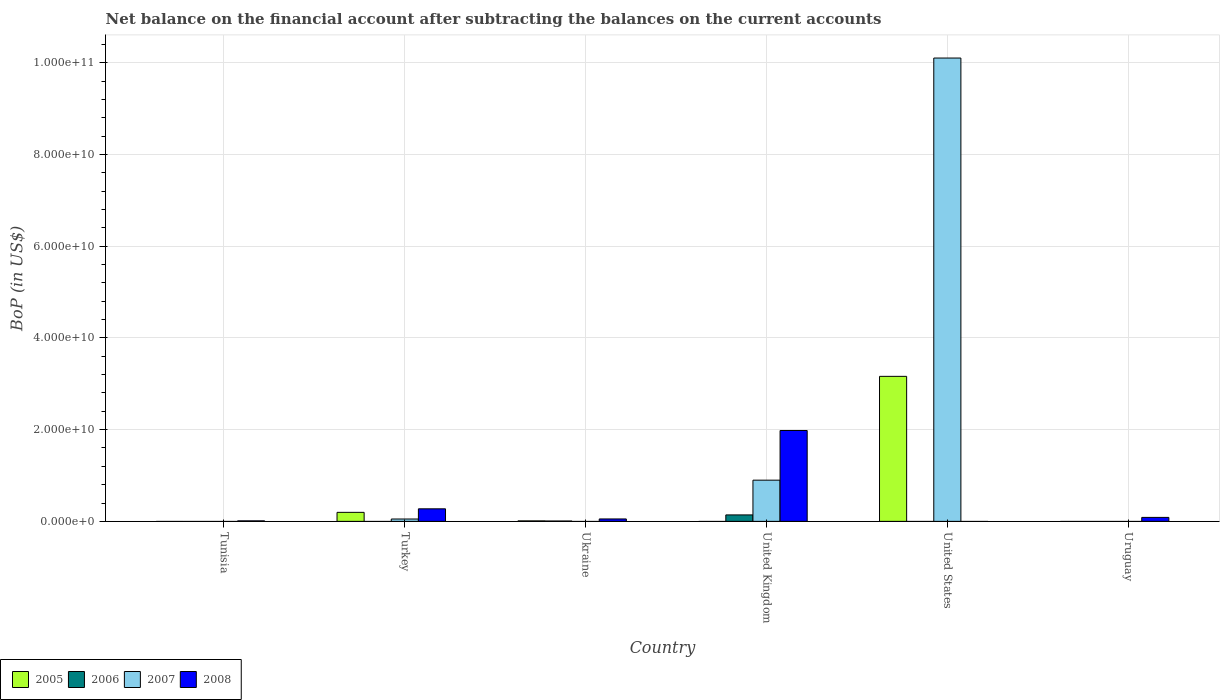How many different coloured bars are there?
Ensure brevity in your answer.  4. Are the number of bars on each tick of the X-axis equal?
Make the answer very short. No. How many bars are there on the 6th tick from the left?
Your answer should be compact. 1. How many bars are there on the 6th tick from the right?
Ensure brevity in your answer.  1. What is the Balance of Payments in 2006 in Ukraine?
Ensure brevity in your answer.  7.60e+07. Across all countries, what is the maximum Balance of Payments in 2007?
Provide a short and direct response. 1.01e+11. In which country was the Balance of Payments in 2005 maximum?
Your response must be concise. United States. What is the total Balance of Payments in 2005 in the graph?
Your answer should be very brief. 3.37e+1. What is the difference between the Balance of Payments in 2007 in United Kingdom and that in United States?
Your answer should be very brief. -9.20e+1. What is the difference between the Balance of Payments in 2008 in Tunisia and the Balance of Payments in 2007 in Ukraine?
Your answer should be compact. 1.13e+08. What is the average Balance of Payments in 2006 per country?
Offer a terse response. 2.47e+08. What is the difference between the Balance of Payments of/in 2005 and Balance of Payments of/in 2006 in Ukraine?
Your answer should be very brief. 2.80e+07. In how many countries, is the Balance of Payments in 2006 greater than 96000000000 US$?
Make the answer very short. 0. What is the difference between the highest and the second highest Balance of Payments in 2007?
Your response must be concise. 9.20e+1. What is the difference between the highest and the lowest Balance of Payments in 2008?
Your answer should be compact. 1.98e+1. In how many countries, is the Balance of Payments in 2005 greater than the average Balance of Payments in 2005 taken over all countries?
Ensure brevity in your answer.  1. Is the sum of the Balance of Payments in 2006 in Ukraine and United Kingdom greater than the maximum Balance of Payments in 2005 across all countries?
Give a very brief answer. No. Is it the case that in every country, the sum of the Balance of Payments in 2006 and Balance of Payments in 2007 is greater than the sum of Balance of Payments in 2008 and Balance of Payments in 2005?
Provide a succinct answer. No. Is it the case that in every country, the sum of the Balance of Payments in 2007 and Balance of Payments in 2005 is greater than the Balance of Payments in 2006?
Make the answer very short. No. Are the values on the major ticks of Y-axis written in scientific E-notation?
Your response must be concise. Yes. Does the graph contain any zero values?
Give a very brief answer. Yes. Where does the legend appear in the graph?
Ensure brevity in your answer.  Bottom left. How many legend labels are there?
Your answer should be very brief. 4. How are the legend labels stacked?
Your answer should be very brief. Horizontal. What is the title of the graph?
Your answer should be compact. Net balance on the financial account after subtracting the balances on the current accounts. What is the label or title of the Y-axis?
Ensure brevity in your answer.  BoP (in US$). What is the BoP (in US$) in 2006 in Tunisia?
Make the answer very short. 0. What is the BoP (in US$) of 2007 in Tunisia?
Provide a short and direct response. 0. What is the BoP (in US$) of 2008 in Tunisia?
Your response must be concise. 1.13e+08. What is the BoP (in US$) in 2005 in Turkey?
Your answer should be compact. 1.96e+09. What is the BoP (in US$) in 2006 in Turkey?
Your answer should be compact. 0. What is the BoP (in US$) in 2007 in Turkey?
Keep it short and to the point. 5.15e+08. What is the BoP (in US$) in 2008 in Turkey?
Your answer should be very brief. 2.73e+09. What is the BoP (in US$) of 2005 in Ukraine?
Provide a succinct answer. 1.04e+08. What is the BoP (in US$) of 2006 in Ukraine?
Make the answer very short. 7.60e+07. What is the BoP (in US$) in 2007 in Ukraine?
Ensure brevity in your answer.  0. What is the BoP (in US$) in 2008 in Ukraine?
Offer a very short reply. 5.26e+08. What is the BoP (in US$) in 2005 in United Kingdom?
Your answer should be very brief. 0. What is the BoP (in US$) in 2006 in United Kingdom?
Offer a terse response. 1.41e+09. What is the BoP (in US$) in 2007 in United Kingdom?
Your answer should be very brief. 8.98e+09. What is the BoP (in US$) of 2008 in United Kingdom?
Offer a very short reply. 1.98e+1. What is the BoP (in US$) of 2005 in United States?
Your answer should be very brief. 3.16e+1. What is the BoP (in US$) of 2006 in United States?
Your answer should be very brief. 0. What is the BoP (in US$) of 2007 in United States?
Offer a terse response. 1.01e+11. What is the BoP (in US$) of 2008 in United States?
Keep it short and to the point. 0. What is the BoP (in US$) of 2008 in Uruguay?
Ensure brevity in your answer.  8.64e+08. Across all countries, what is the maximum BoP (in US$) in 2005?
Provide a short and direct response. 3.16e+1. Across all countries, what is the maximum BoP (in US$) in 2006?
Keep it short and to the point. 1.41e+09. Across all countries, what is the maximum BoP (in US$) in 2007?
Keep it short and to the point. 1.01e+11. Across all countries, what is the maximum BoP (in US$) in 2008?
Your answer should be very brief. 1.98e+1. Across all countries, what is the minimum BoP (in US$) of 2005?
Your answer should be very brief. 0. Across all countries, what is the minimum BoP (in US$) of 2006?
Offer a terse response. 0. Across all countries, what is the minimum BoP (in US$) of 2007?
Your response must be concise. 0. Across all countries, what is the minimum BoP (in US$) of 2008?
Make the answer very short. 0. What is the total BoP (in US$) in 2005 in the graph?
Provide a succinct answer. 3.37e+1. What is the total BoP (in US$) in 2006 in the graph?
Your answer should be compact. 1.48e+09. What is the total BoP (in US$) in 2007 in the graph?
Offer a terse response. 1.11e+11. What is the total BoP (in US$) in 2008 in the graph?
Provide a short and direct response. 2.40e+1. What is the difference between the BoP (in US$) in 2008 in Tunisia and that in Turkey?
Your answer should be very brief. -2.62e+09. What is the difference between the BoP (in US$) of 2008 in Tunisia and that in Ukraine?
Make the answer very short. -4.13e+08. What is the difference between the BoP (in US$) in 2008 in Tunisia and that in United Kingdom?
Keep it short and to the point. -1.97e+1. What is the difference between the BoP (in US$) of 2008 in Tunisia and that in Uruguay?
Offer a very short reply. -7.51e+08. What is the difference between the BoP (in US$) of 2005 in Turkey and that in Ukraine?
Provide a short and direct response. 1.86e+09. What is the difference between the BoP (in US$) of 2008 in Turkey and that in Ukraine?
Offer a terse response. 2.21e+09. What is the difference between the BoP (in US$) of 2007 in Turkey and that in United Kingdom?
Provide a short and direct response. -8.47e+09. What is the difference between the BoP (in US$) in 2008 in Turkey and that in United Kingdom?
Give a very brief answer. -1.71e+1. What is the difference between the BoP (in US$) of 2005 in Turkey and that in United States?
Offer a very short reply. -2.96e+1. What is the difference between the BoP (in US$) of 2007 in Turkey and that in United States?
Provide a succinct answer. -1.00e+11. What is the difference between the BoP (in US$) of 2008 in Turkey and that in Uruguay?
Keep it short and to the point. 1.87e+09. What is the difference between the BoP (in US$) in 2006 in Ukraine and that in United Kingdom?
Offer a terse response. -1.33e+09. What is the difference between the BoP (in US$) of 2008 in Ukraine and that in United Kingdom?
Keep it short and to the point. -1.93e+1. What is the difference between the BoP (in US$) of 2005 in Ukraine and that in United States?
Your answer should be very brief. -3.15e+1. What is the difference between the BoP (in US$) of 2008 in Ukraine and that in Uruguay?
Offer a terse response. -3.38e+08. What is the difference between the BoP (in US$) in 2007 in United Kingdom and that in United States?
Offer a very short reply. -9.20e+1. What is the difference between the BoP (in US$) of 2008 in United Kingdom and that in Uruguay?
Your answer should be compact. 1.89e+1. What is the difference between the BoP (in US$) of 2005 in Turkey and the BoP (in US$) of 2006 in Ukraine?
Make the answer very short. 1.89e+09. What is the difference between the BoP (in US$) of 2005 in Turkey and the BoP (in US$) of 2008 in Ukraine?
Provide a short and direct response. 1.44e+09. What is the difference between the BoP (in US$) in 2007 in Turkey and the BoP (in US$) in 2008 in Ukraine?
Provide a succinct answer. -1.10e+07. What is the difference between the BoP (in US$) in 2005 in Turkey and the BoP (in US$) in 2006 in United Kingdom?
Offer a terse response. 5.57e+08. What is the difference between the BoP (in US$) in 2005 in Turkey and the BoP (in US$) in 2007 in United Kingdom?
Your response must be concise. -7.02e+09. What is the difference between the BoP (in US$) of 2005 in Turkey and the BoP (in US$) of 2008 in United Kingdom?
Your response must be concise. -1.78e+1. What is the difference between the BoP (in US$) of 2007 in Turkey and the BoP (in US$) of 2008 in United Kingdom?
Offer a terse response. -1.93e+1. What is the difference between the BoP (in US$) in 2005 in Turkey and the BoP (in US$) in 2007 in United States?
Provide a short and direct response. -9.90e+1. What is the difference between the BoP (in US$) in 2005 in Turkey and the BoP (in US$) in 2008 in Uruguay?
Your response must be concise. 1.10e+09. What is the difference between the BoP (in US$) of 2007 in Turkey and the BoP (in US$) of 2008 in Uruguay?
Ensure brevity in your answer.  -3.49e+08. What is the difference between the BoP (in US$) in 2005 in Ukraine and the BoP (in US$) in 2006 in United Kingdom?
Your answer should be very brief. -1.30e+09. What is the difference between the BoP (in US$) in 2005 in Ukraine and the BoP (in US$) in 2007 in United Kingdom?
Give a very brief answer. -8.88e+09. What is the difference between the BoP (in US$) of 2005 in Ukraine and the BoP (in US$) of 2008 in United Kingdom?
Make the answer very short. -1.97e+1. What is the difference between the BoP (in US$) of 2006 in Ukraine and the BoP (in US$) of 2007 in United Kingdom?
Make the answer very short. -8.91e+09. What is the difference between the BoP (in US$) in 2006 in Ukraine and the BoP (in US$) in 2008 in United Kingdom?
Provide a succinct answer. -1.97e+1. What is the difference between the BoP (in US$) of 2005 in Ukraine and the BoP (in US$) of 2007 in United States?
Give a very brief answer. -1.01e+11. What is the difference between the BoP (in US$) of 2006 in Ukraine and the BoP (in US$) of 2007 in United States?
Ensure brevity in your answer.  -1.01e+11. What is the difference between the BoP (in US$) in 2005 in Ukraine and the BoP (in US$) in 2008 in Uruguay?
Offer a terse response. -7.60e+08. What is the difference between the BoP (in US$) in 2006 in Ukraine and the BoP (in US$) in 2008 in Uruguay?
Provide a succinct answer. -7.88e+08. What is the difference between the BoP (in US$) in 2006 in United Kingdom and the BoP (in US$) in 2007 in United States?
Make the answer very short. -9.96e+1. What is the difference between the BoP (in US$) of 2006 in United Kingdom and the BoP (in US$) of 2008 in Uruguay?
Provide a succinct answer. 5.43e+08. What is the difference between the BoP (in US$) of 2007 in United Kingdom and the BoP (in US$) of 2008 in Uruguay?
Provide a short and direct response. 8.12e+09. What is the difference between the BoP (in US$) of 2005 in United States and the BoP (in US$) of 2008 in Uruguay?
Keep it short and to the point. 3.08e+1. What is the difference between the BoP (in US$) of 2007 in United States and the BoP (in US$) of 2008 in Uruguay?
Give a very brief answer. 1.00e+11. What is the average BoP (in US$) in 2005 per country?
Make the answer very short. 5.61e+09. What is the average BoP (in US$) of 2006 per country?
Make the answer very short. 2.47e+08. What is the average BoP (in US$) of 2007 per country?
Provide a short and direct response. 1.84e+1. What is the average BoP (in US$) in 2008 per country?
Your response must be concise. 4.01e+09. What is the difference between the BoP (in US$) in 2005 and BoP (in US$) in 2007 in Turkey?
Offer a terse response. 1.45e+09. What is the difference between the BoP (in US$) of 2005 and BoP (in US$) of 2008 in Turkey?
Ensure brevity in your answer.  -7.69e+08. What is the difference between the BoP (in US$) of 2007 and BoP (in US$) of 2008 in Turkey?
Provide a succinct answer. -2.22e+09. What is the difference between the BoP (in US$) of 2005 and BoP (in US$) of 2006 in Ukraine?
Give a very brief answer. 2.80e+07. What is the difference between the BoP (in US$) in 2005 and BoP (in US$) in 2008 in Ukraine?
Give a very brief answer. -4.22e+08. What is the difference between the BoP (in US$) in 2006 and BoP (in US$) in 2008 in Ukraine?
Your response must be concise. -4.50e+08. What is the difference between the BoP (in US$) in 2006 and BoP (in US$) in 2007 in United Kingdom?
Your response must be concise. -7.57e+09. What is the difference between the BoP (in US$) in 2006 and BoP (in US$) in 2008 in United Kingdom?
Your response must be concise. -1.84e+1. What is the difference between the BoP (in US$) in 2007 and BoP (in US$) in 2008 in United Kingdom?
Make the answer very short. -1.08e+1. What is the difference between the BoP (in US$) of 2005 and BoP (in US$) of 2007 in United States?
Offer a terse response. -6.94e+1. What is the ratio of the BoP (in US$) in 2008 in Tunisia to that in Turkey?
Your response must be concise. 0.04. What is the ratio of the BoP (in US$) of 2008 in Tunisia to that in Ukraine?
Give a very brief answer. 0.21. What is the ratio of the BoP (in US$) in 2008 in Tunisia to that in United Kingdom?
Give a very brief answer. 0.01. What is the ratio of the BoP (in US$) of 2008 in Tunisia to that in Uruguay?
Your answer should be very brief. 0.13. What is the ratio of the BoP (in US$) in 2005 in Turkey to that in Ukraine?
Your response must be concise. 18.88. What is the ratio of the BoP (in US$) in 2008 in Turkey to that in Ukraine?
Ensure brevity in your answer.  5.2. What is the ratio of the BoP (in US$) of 2007 in Turkey to that in United Kingdom?
Keep it short and to the point. 0.06. What is the ratio of the BoP (in US$) of 2008 in Turkey to that in United Kingdom?
Give a very brief answer. 0.14. What is the ratio of the BoP (in US$) of 2005 in Turkey to that in United States?
Provide a succinct answer. 0.06. What is the ratio of the BoP (in US$) in 2007 in Turkey to that in United States?
Offer a terse response. 0.01. What is the ratio of the BoP (in US$) in 2008 in Turkey to that in Uruguay?
Your response must be concise. 3.16. What is the ratio of the BoP (in US$) in 2006 in Ukraine to that in United Kingdom?
Your response must be concise. 0.05. What is the ratio of the BoP (in US$) in 2008 in Ukraine to that in United Kingdom?
Your response must be concise. 0.03. What is the ratio of the BoP (in US$) of 2005 in Ukraine to that in United States?
Your response must be concise. 0. What is the ratio of the BoP (in US$) in 2008 in Ukraine to that in Uruguay?
Keep it short and to the point. 0.61. What is the ratio of the BoP (in US$) in 2007 in United Kingdom to that in United States?
Your answer should be compact. 0.09. What is the ratio of the BoP (in US$) of 2008 in United Kingdom to that in Uruguay?
Ensure brevity in your answer.  22.93. What is the difference between the highest and the second highest BoP (in US$) in 2005?
Make the answer very short. 2.96e+1. What is the difference between the highest and the second highest BoP (in US$) in 2007?
Make the answer very short. 9.20e+1. What is the difference between the highest and the second highest BoP (in US$) in 2008?
Offer a very short reply. 1.71e+1. What is the difference between the highest and the lowest BoP (in US$) in 2005?
Provide a short and direct response. 3.16e+1. What is the difference between the highest and the lowest BoP (in US$) in 2006?
Make the answer very short. 1.41e+09. What is the difference between the highest and the lowest BoP (in US$) in 2007?
Make the answer very short. 1.01e+11. What is the difference between the highest and the lowest BoP (in US$) of 2008?
Give a very brief answer. 1.98e+1. 